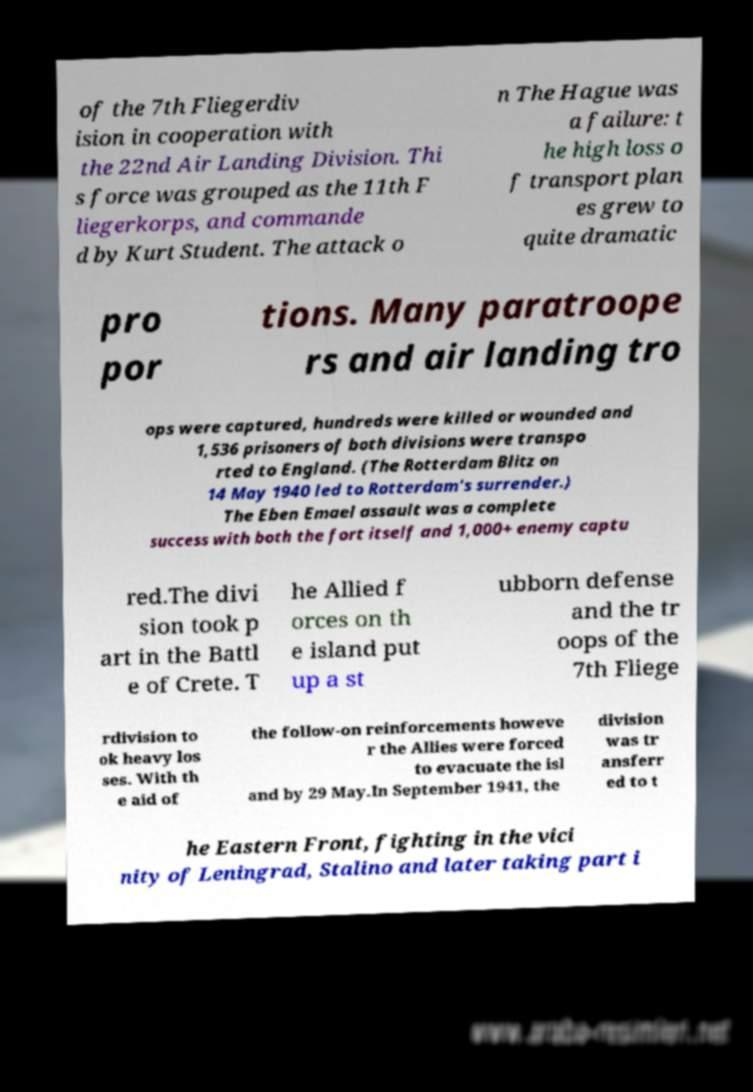Could you assist in decoding the text presented in this image and type it out clearly? of the 7th Fliegerdiv ision in cooperation with the 22nd Air Landing Division. Thi s force was grouped as the 11th F liegerkorps, and commande d by Kurt Student. The attack o n The Hague was a failure: t he high loss o f transport plan es grew to quite dramatic pro por tions. Many paratroope rs and air landing tro ops were captured, hundreds were killed or wounded and 1,536 prisoners of both divisions were transpo rted to England. (The Rotterdam Blitz on 14 May 1940 led to Rotterdam's surrender.) The Eben Emael assault was a complete success with both the fort itself and 1,000+ enemy captu red.The divi sion took p art in the Battl e of Crete. T he Allied f orces on th e island put up a st ubborn defense and the tr oops of the 7th Fliege rdivision to ok heavy los ses. With th e aid of the follow-on reinforcements howeve r the Allies were forced to evacuate the isl and by 29 May.In September 1941, the division was tr ansferr ed to t he Eastern Front, fighting in the vici nity of Leningrad, Stalino and later taking part i 